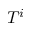<formula> <loc_0><loc_0><loc_500><loc_500>T ^ { i }</formula> 